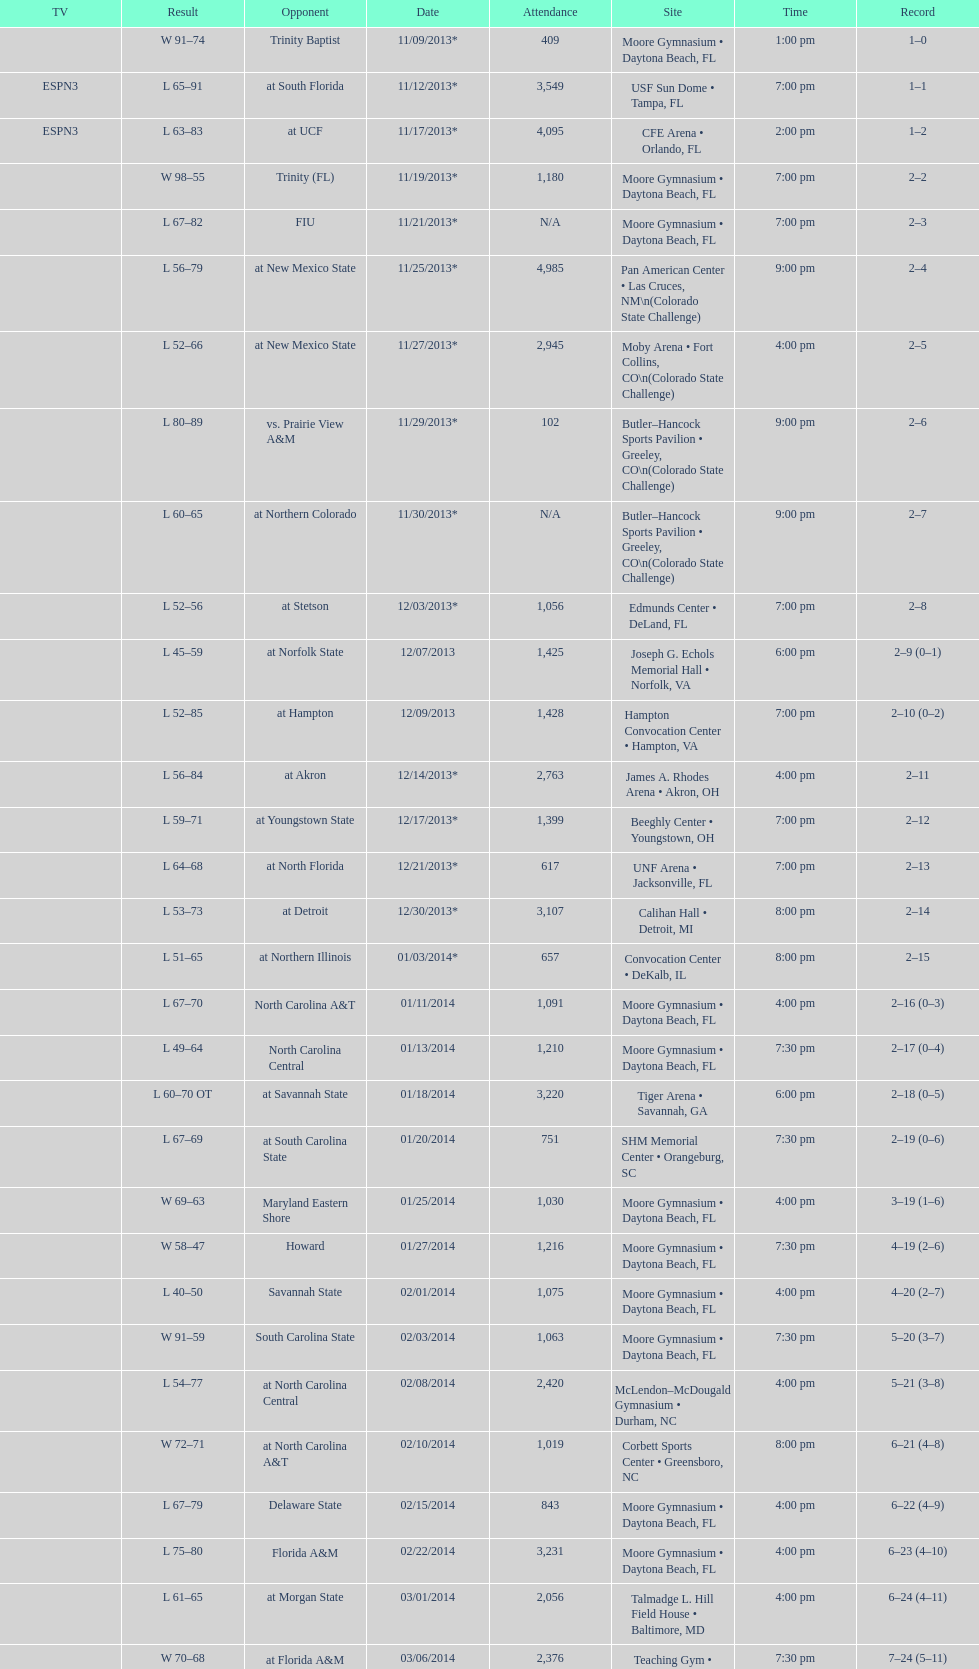Which game had a more significant win, against trinity (fl) or against trinity baptist? Trinity (FL). 